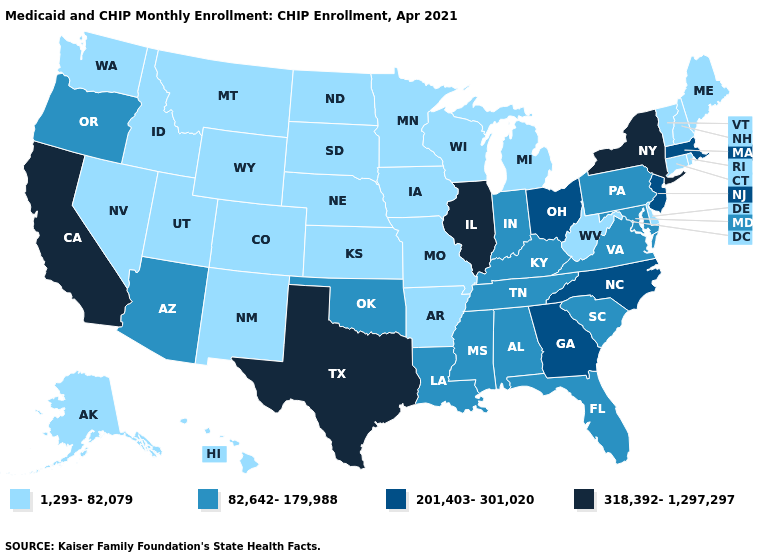Name the states that have a value in the range 201,403-301,020?
Keep it brief. Georgia, Massachusetts, New Jersey, North Carolina, Ohio. What is the value of Indiana?
Answer briefly. 82,642-179,988. What is the highest value in the South ?
Quick response, please. 318,392-1,297,297. What is the value of Georgia?
Write a very short answer. 201,403-301,020. Does California have the same value as South Carolina?
Be succinct. No. What is the highest value in the USA?
Answer briefly. 318,392-1,297,297. Is the legend a continuous bar?
Concise answer only. No. Which states have the highest value in the USA?
Keep it brief. California, Illinois, New York, Texas. Among the states that border California , does Arizona have the lowest value?
Quick response, please. No. What is the lowest value in the South?
Answer briefly. 1,293-82,079. Among the states that border Indiana , which have the highest value?
Concise answer only. Illinois. Which states have the highest value in the USA?
Answer briefly. California, Illinois, New York, Texas. What is the lowest value in states that border Missouri?
Keep it brief. 1,293-82,079. Among the states that border Texas , which have the highest value?
Concise answer only. Louisiana, Oklahoma. Among the states that border Louisiana , which have the highest value?
Write a very short answer. Texas. 